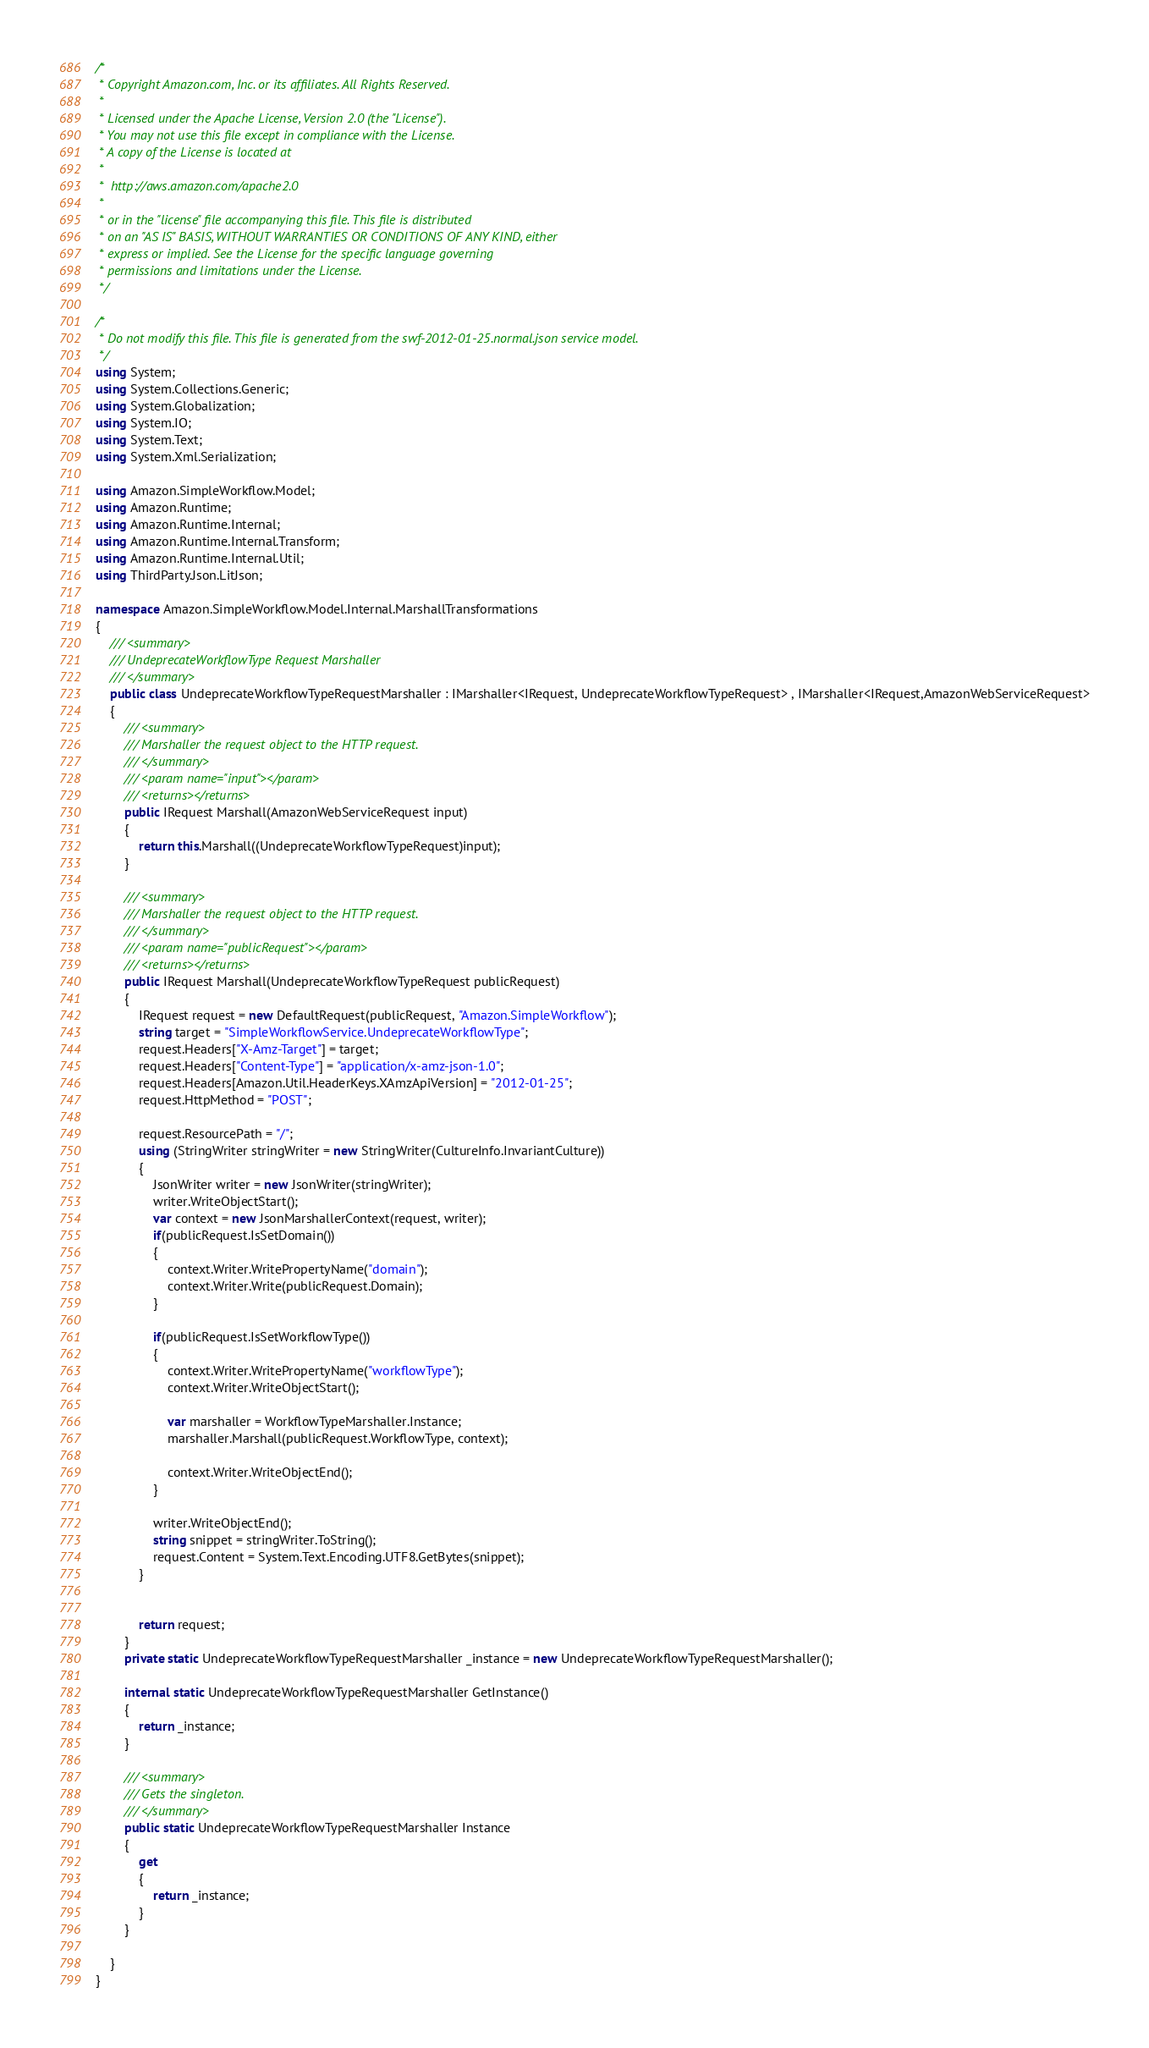Convert code to text. <code><loc_0><loc_0><loc_500><loc_500><_C#_>/*
 * Copyright Amazon.com, Inc. or its affiliates. All Rights Reserved.
 * 
 * Licensed under the Apache License, Version 2.0 (the "License").
 * You may not use this file except in compliance with the License.
 * A copy of the License is located at
 * 
 *  http://aws.amazon.com/apache2.0
 * 
 * or in the "license" file accompanying this file. This file is distributed
 * on an "AS IS" BASIS, WITHOUT WARRANTIES OR CONDITIONS OF ANY KIND, either
 * express or implied. See the License for the specific language governing
 * permissions and limitations under the License.
 */

/*
 * Do not modify this file. This file is generated from the swf-2012-01-25.normal.json service model.
 */
using System;
using System.Collections.Generic;
using System.Globalization;
using System.IO;
using System.Text;
using System.Xml.Serialization;

using Amazon.SimpleWorkflow.Model;
using Amazon.Runtime;
using Amazon.Runtime.Internal;
using Amazon.Runtime.Internal.Transform;
using Amazon.Runtime.Internal.Util;
using ThirdParty.Json.LitJson;

namespace Amazon.SimpleWorkflow.Model.Internal.MarshallTransformations
{
    /// <summary>
    /// UndeprecateWorkflowType Request Marshaller
    /// </summary>       
    public class UndeprecateWorkflowTypeRequestMarshaller : IMarshaller<IRequest, UndeprecateWorkflowTypeRequest> , IMarshaller<IRequest,AmazonWebServiceRequest>
    {
        /// <summary>
        /// Marshaller the request object to the HTTP request.
        /// </summary>  
        /// <param name="input"></param>
        /// <returns></returns>
        public IRequest Marshall(AmazonWebServiceRequest input)
        {
            return this.Marshall((UndeprecateWorkflowTypeRequest)input);
        }

        /// <summary>
        /// Marshaller the request object to the HTTP request.
        /// </summary>  
        /// <param name="publicRequest"></param>
        /// <returns></returns>
        public IRequest Marshall(UndeprecateWorkflowTypeRequest publicRequest)
        {
            IRequest request = new DefaultRequest(publicRequest, "Amazon.SimpleWorkflow");
            string target = "SimpleWorkflowService.UndeprecateWorkflowType";
            request.Headers["X-Amz-Target"] = target;
            request.Headers["Content-Type"] = "application/x-amz-json-1.0";
            request.Headers[Amazon.Util.HeaderKeys.XAmzApiVersion] = "2012-01-25";
            request.HttpMethod = "POST";

            request.ResourcePath = "/";
            using (StringWriter stringWriter = new StringWriter(CultureInfo.InvariantCulture))
            {
                JsonWriter writer = new JsonWriter(stringWriter);
                writer.WriteObjectStart();
                var context = new JsonMarshallerContext(request, writer);
                if(publicRequest.IsSetDomain())
                {
                    context.Writer.WritePropertyName("domain");
                    context.Writer.Write(publicRequest.Domain);
                }

                if(publicRequest.IsSetWorkflowType())
                {
                    context.Writer.WritePropertyName("workflowType");
                    context.Writer.WriteObjectStart();

                    var marshaller = WorkflowTypeMarshaller.Instance;
                    marshaller.Marshall(publicRequest.WorkflowType, context);

                    context.Writer.WriteObjectEnd();
                }

                writer.WriteObjectEnd();
                string snippet = stringWriter.ToString();
                request.Content = System.Text.Encoding.UTF8.GetBytes(snippet);
            }


            return request;
        }
        private static UndeprecateWorkflowTypeRequestMarshaller _instance = new UndeprecateWorkflowTypeRequestMarshaller();        

        internal static UndeprecateWorkflowTypeRequestMarshaller GetInstance()
        {
            return _instance;
        }

        /// <summary>
        /// Gets the singleton.
        /// </summary>  
        public static UndeprecateWorkflowTypeRequestMarshaller Instance
        {
            get
            {
                return _instance;
            }
        }

    }
}</code> 